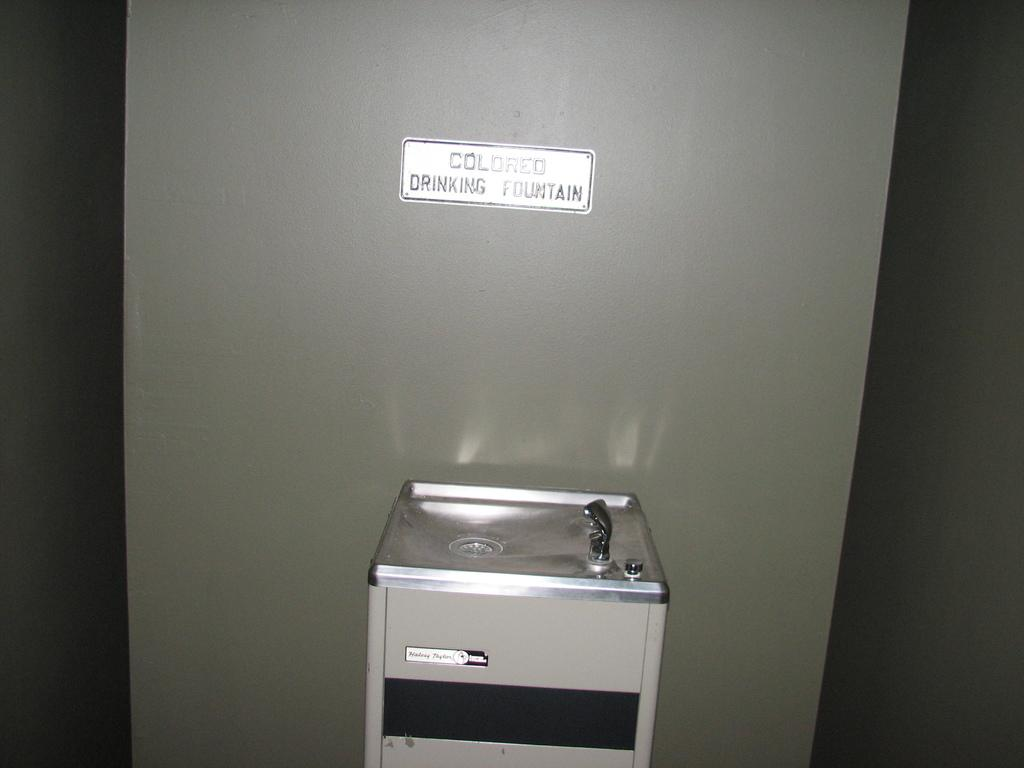<image>
Offer a succinct explanation of the picture presented. a COLORED DRINKING FOUNTAIN sign on the wall with the fountain below it. 